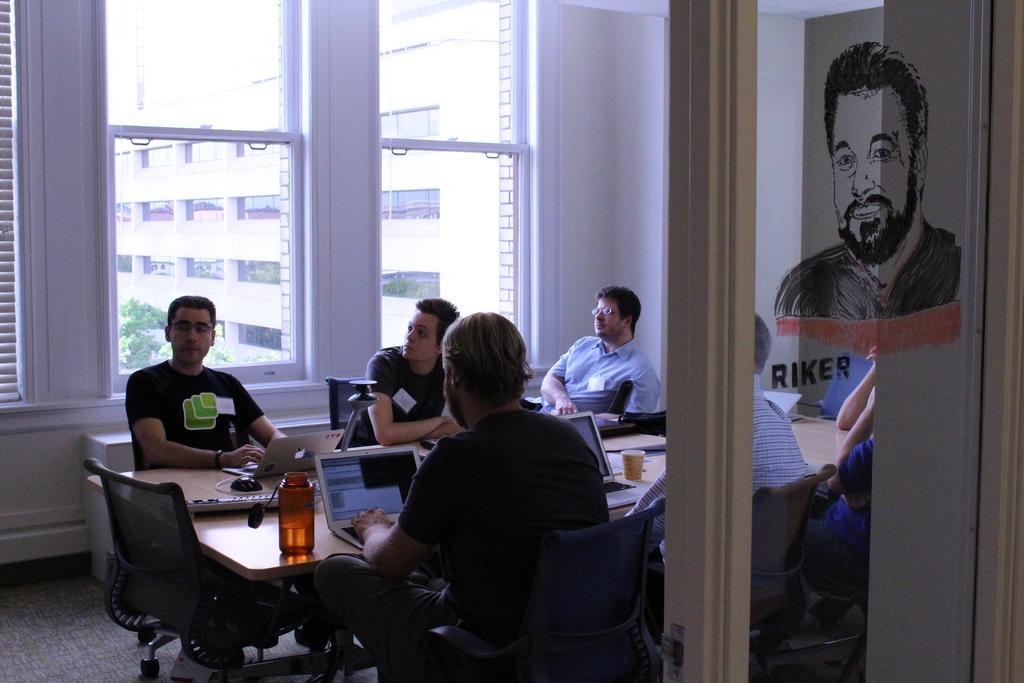In one or two sentences, can you explain what this image depicts? In this image there are group of people sitting in chair and in table there is cup, laptop, mouse, keyboard, bottle and in background there is building , tree, window. 